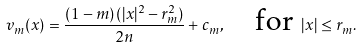<formula> <loc_0><loc_0><loc_500><loc_500>v _ { m } ( x ) = \frac { ( 1 - m ) \, ( | x | ^ { 2 } - r _ { m } ^ { 2 } ) } { 2 n } + c _ { m } , \quad \text {for } | x | \leq r _ { m } .</formula> 